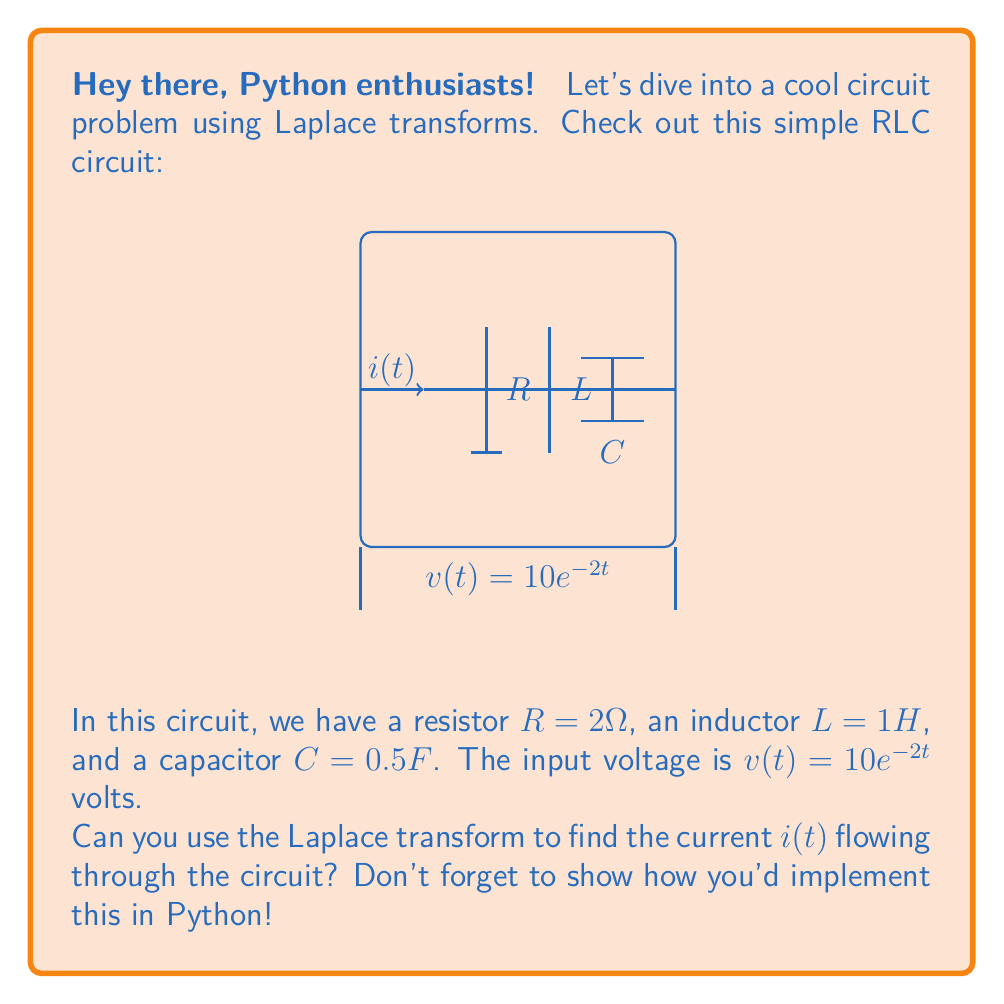Could you help me with this problem? Alright, let's break this down step-by-step:

1) First, we need to write the differential equation for the circuit:

   $$L\frac{d^2i}{dt^2} + R\frac{di}{dt} + \frac{1}{C}i = \frac{dv}{dt}$$

2) Substituting the given values:

   $$\frac{d^2i}{dt^2} + 2\frac{di}{dt} + 2i = -20e^{-2t}$$

3) Now, let's apply the Laplace transform. We'll use $\mathcal{L}\{i(t)\} = I(s)$:

   $$\mathcal{L}\{\frac{d^2i}{dt^2} + 2\frac{di}{dt} + 2i\} = \mathcal{L}\{-20e^{-2t}\}$$

   $$(s^2I(s) - si(0) - i'(0)) + 2(sI(s) - i(0)) + 2I(s) = -\frac{20}{s+2}$$

4) Assuming initial conditions $i(0) = 0$ and $i'(0) = 0$:

   $$s^2I(s) + 2sI(s) + 2I(s) = -\frac{20}{s+2}$$
   
   $$(s^2 + 2s + 2)I(s) = -\frac{20}{s+2}$$

5) Solving for $I(s)$:

   $$I(s) = -\frac{20}{(s^2 + 2s + 2)(s+2)}$$

6) To find $i(t)$, we need to perform partial fraction decomposition:

   $$I(s) = \frac{A}{s+2} + \frac{Bs+C}{s^2 + 2s + 2}$$

   where $A = -10$, $B = 5$, and $C = -5$

7) Taking the inverse Laplace transform:

   $$i(t) = -10e^{-2t} + 5e^{-t}\cos(t) - 5e^{-t}\sin(t)$$

8) To implement this in Python, we can use the SymPy library:

```python
import sympy as sp
import numpy as np
import matplotlib.pyplot as plt

t = sp.Symbol('t')
i = -10*sp.exp(-2*t) + 5*sp.exp(-t)*sp.cos(t) - 5*sp.exp(-t)*sp.sin(t)

# Convert to lambda function for numpy
i_func = sp.lambdify(t, i, 'numpy')

# Generate time values
t_values = np.linspace(0, 5, 1000)

# Calculate current values
i_values = i_func(t_values)

# Plot the result
plt.figure(figsize=(10, 6))
plt.plot(t_values, i_values)
plt.title('Current i(t) in the RLC Circuit')
plt.xlabel('Time (s)')
plt.ylabel('Current (A)')
plt.grid(True)
plt.show()
```

This code will plot the current $i(t)$ over time, giving us a visual representation of the solution.
Answer: $i(t) = -10e^{-2t} + 5e^{-t}\cos(t) - 5e^{-t}\sin(t)$ 